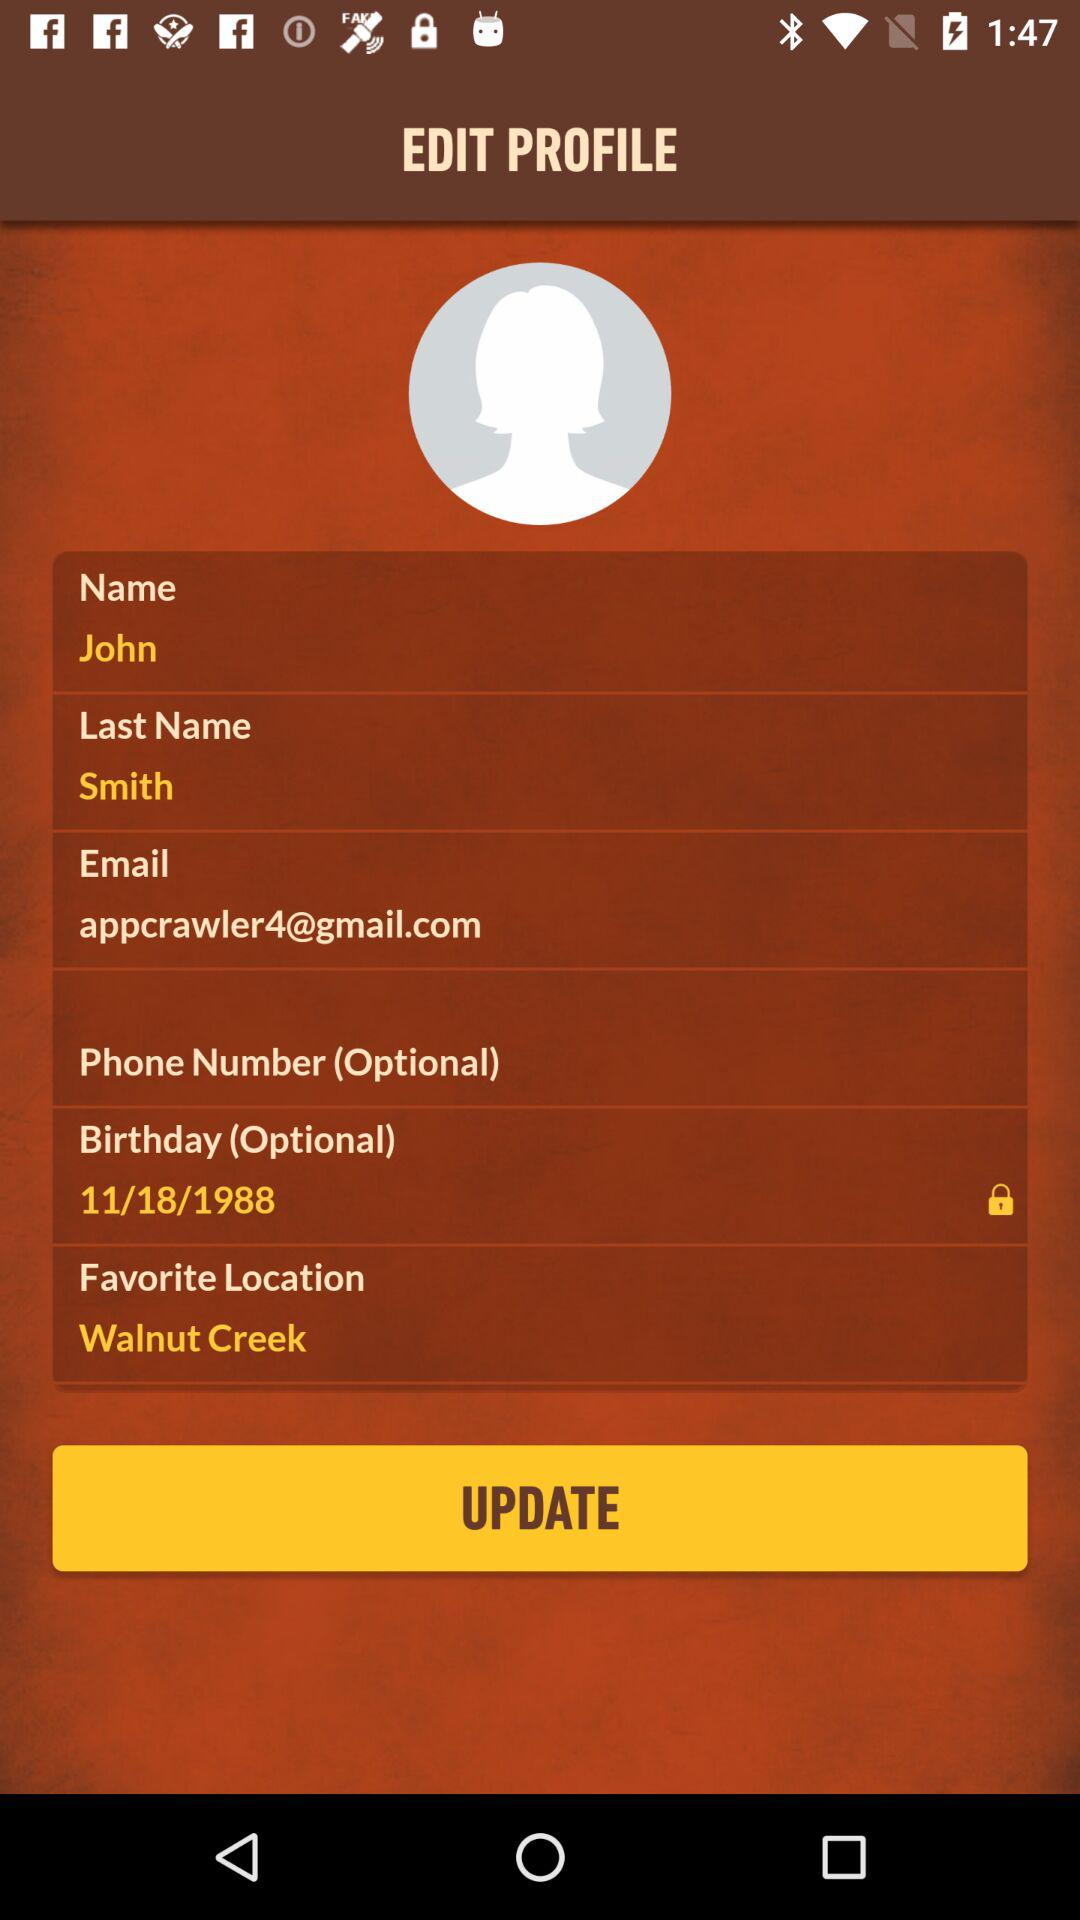What is the favorite location? The favorite location is Walnut Creek. 